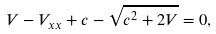Convert formula to latex. <formula><loc_0><loc_0><loc_500><loc_500>V - V _ { x x } + c - \sqrt { c ^ { 2 } + 2 V } = 0 ,</formula> 